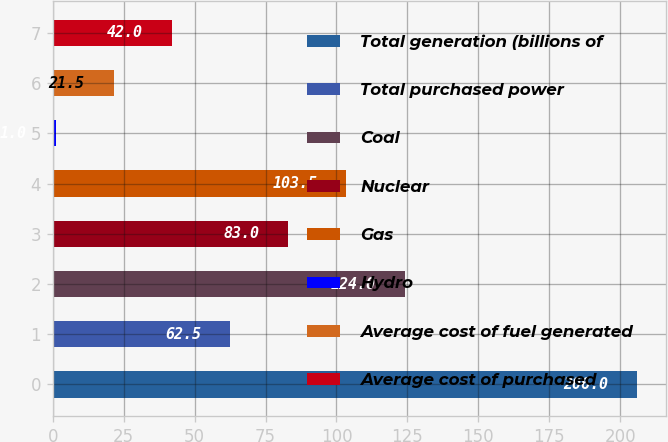Convert chart. <chart><loc_0><loc_0><loc_500><loc_500><bar_chart><fcel>Total generation (billions of<fcel>Total purchased power<fcel>Coal<fcel>Nuclear<fcel>Gas<fcel>Hydro<fcel>Average cost of fuel generated<fcel>Average cost of purchased<nl><fcel>206<fcel>62.5<fcel>124<fcel>83<fcel>103.5<fcel>1<fcel>21.5<fcel>42<nl></chart> 